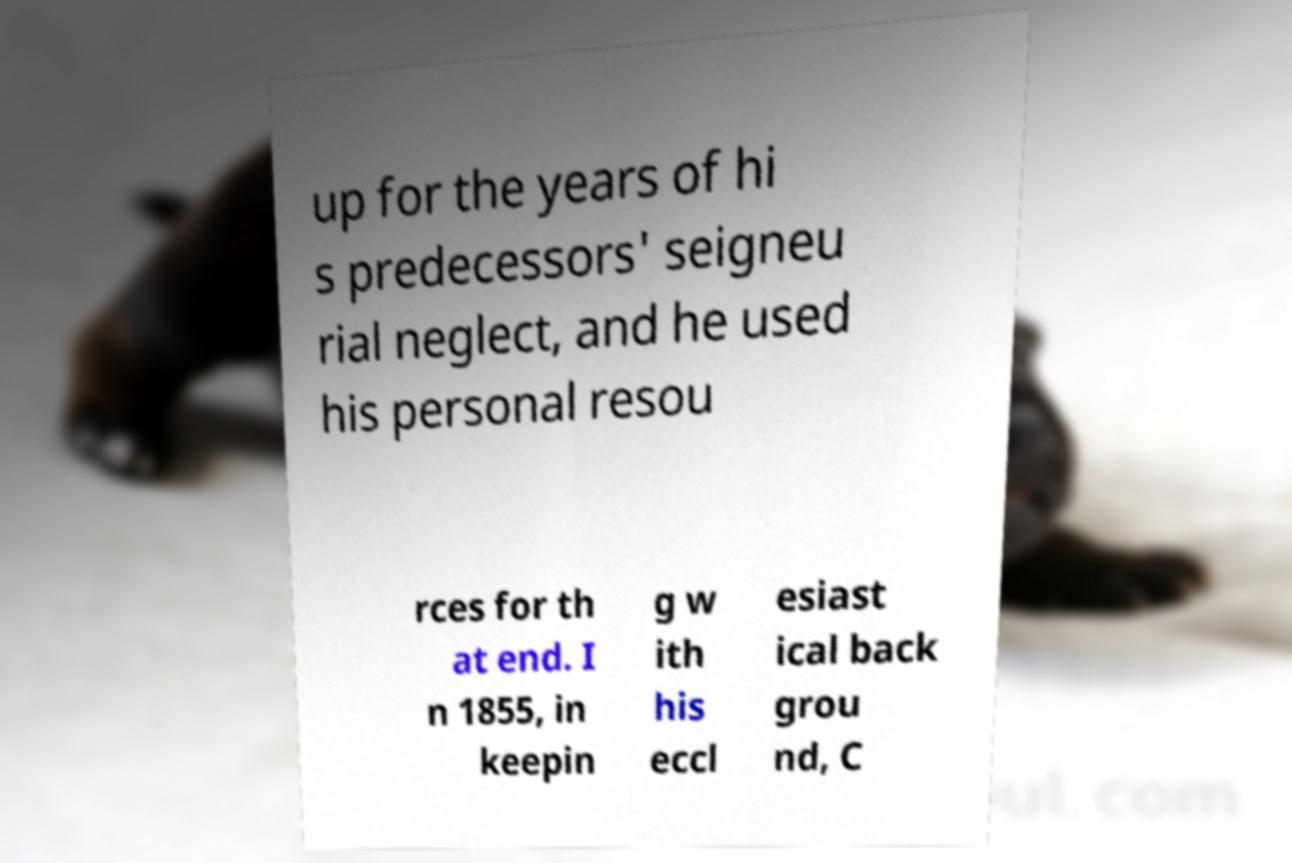For documentation purposes, I need the text within this image transcribed. Could you provide that? up for the years of hi s predecessors' seigneu rial neglect, and he used his personal resou rces for th at end. I n 1855, in keepin g w ith his eccl esiast ical back grou nd, C 